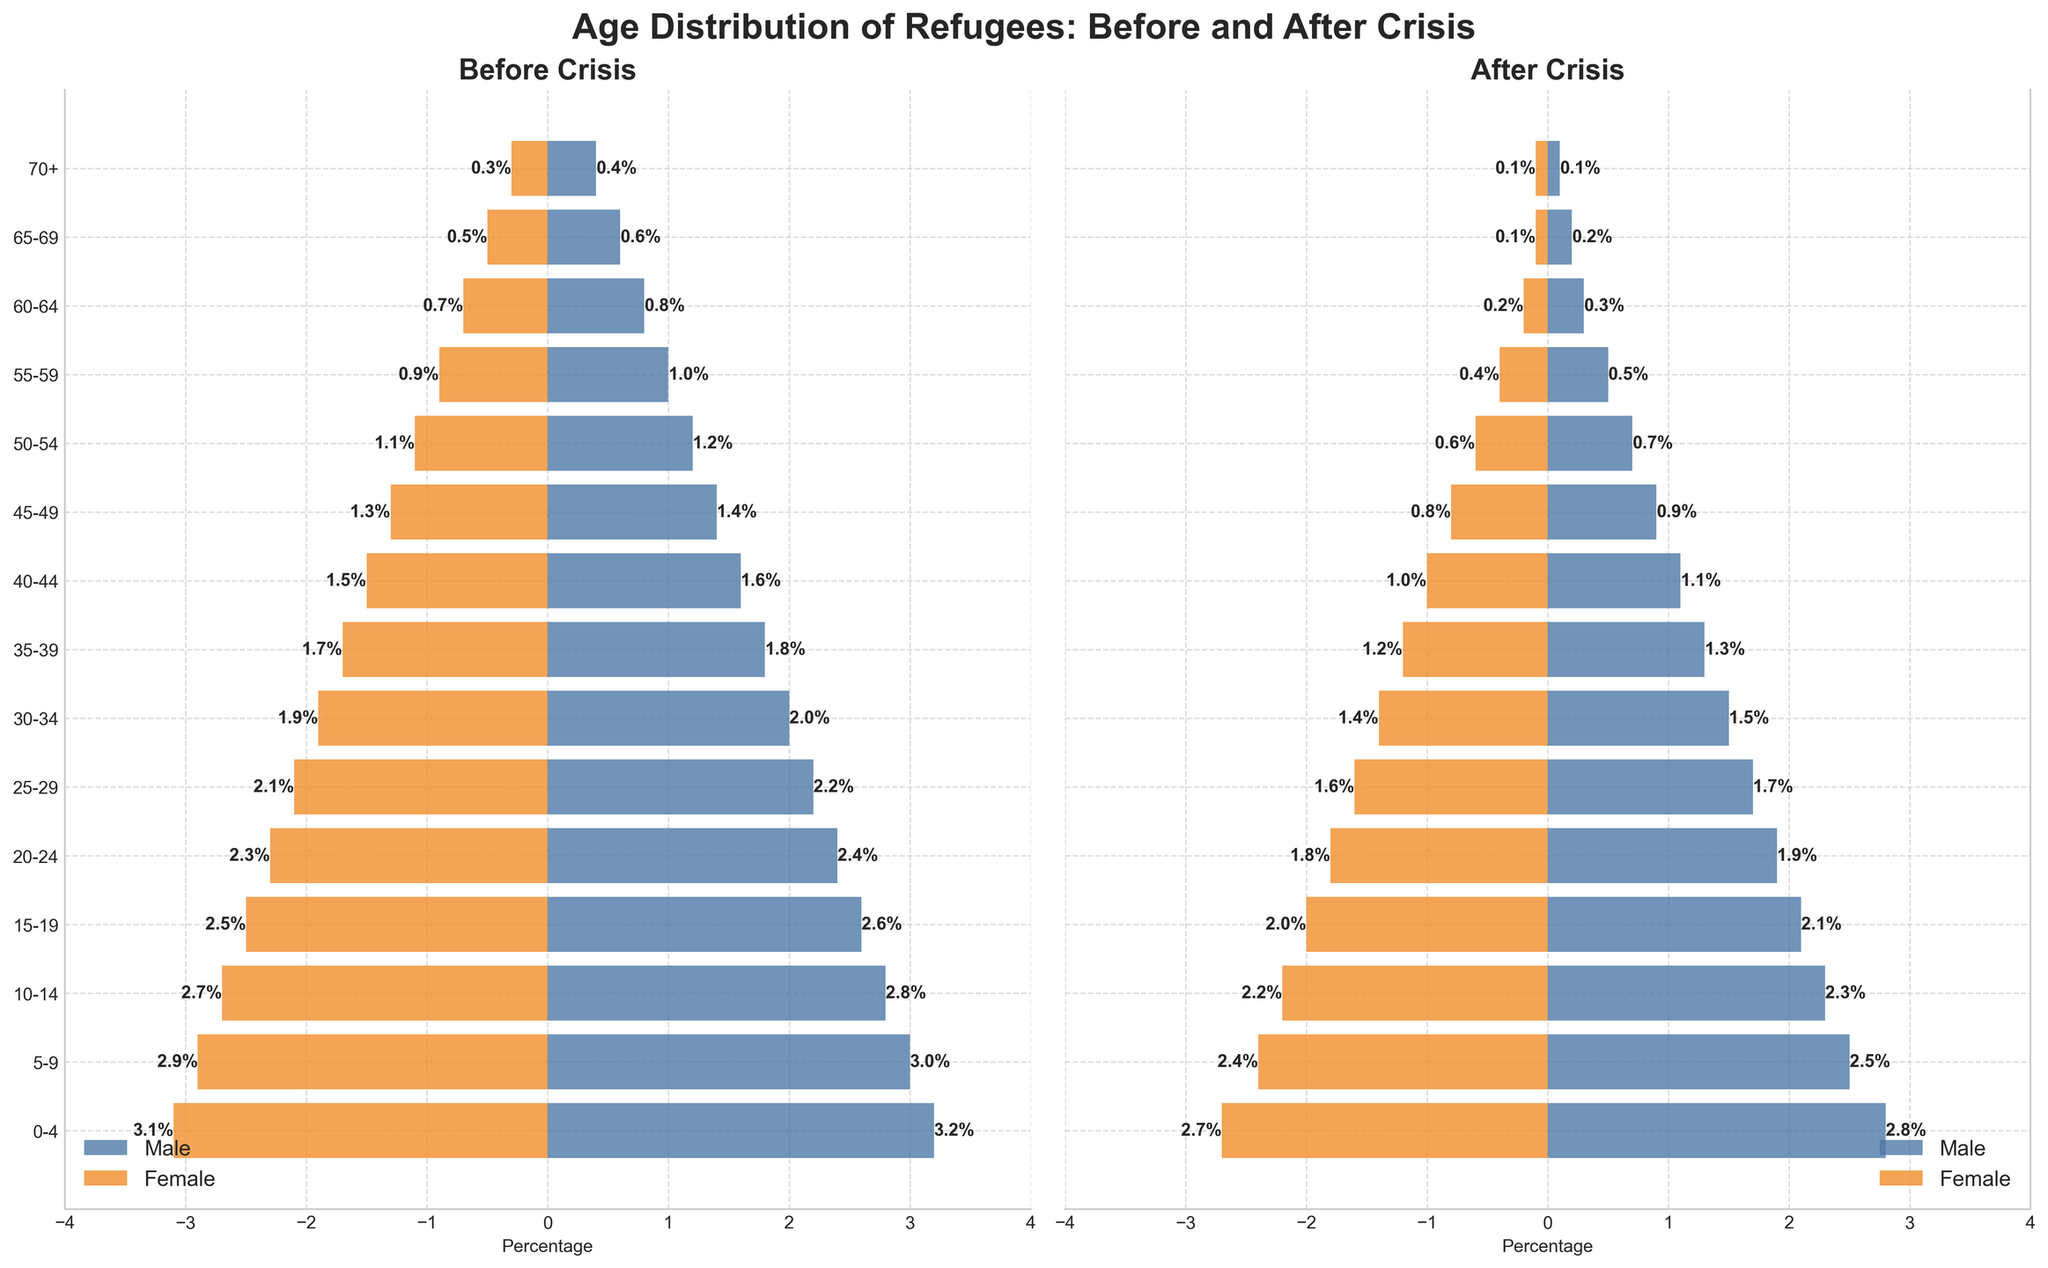What is the title of the figure? The title is displayed at the top of the figure. By looking, we can see it reads "Age Distribution of Refugees: Before and After Crisis".
Answer: Age Distribution of Refugees: Before and After Crisis What are the colors used to represent males and females in the figure? The color for males is blue and the color for females is orange, as indicated by the two distinct bars in each subplot.
Answer: Blue for males, Orange for females How many age groups are represented in the figure? Each age group is listed on the y-axis. Counting them gives us a total number.
Answer: 15 In the 'After Crisis' subplot, what percentage of refugees are males in the 30-34 age group? To find this, look at the corresponding horizontal bar for the 30-34 age group in the 'After Crisis' subplot and read the value.
Answer: 1.5% What's the difference in the percentage of males in the 50-54 age group, before and after the crisis? To solve this, subtract the 'After Crisis' value from the 'Before Crisis' value for males in the 50-54 age group. Specifically, 1.2% - 0.7% = 0.5%.
Answer: 0.5% Which age group saw the greatest decrease in the percentage of female refugees from before to after the crisis? Compare the percentage decrease for each age group by calculating the differences and identifying the largest one. The difference for the 65-69 age group is the largest, 0.5% - 0.1% = 0.4%.
Answer: 65-69 What's the total percentage of female refugees in the 10-19 age groups before the crisis? Add the percentages for females in the 10-14 and 15-19 age groups. So, 2.7% + 2.5% = 5.2%.
Answer: 5.2% Which gender saw a larger reduction in the percentage of refugees in the 0-4 age group after the crisis? Calculate the differences for both genders in the 0-4 age group, compare which one is bigger. Males decreased by 0.4% (3.2% - 2.8%) and females decreased by 0.4% (3.1% - 2.7%). They are equal.
Answer: Neither, both saw a reduction of 0.4% For the 40-44 age group after the crisis, is the percentage of male refugees higher or lower than the percentage of female refugees in the same age group? Compare the values in the respective age group for males and females in the 'After Crisis' subplot. Males have 1.1% and females have 1.0%.
Answer: Higher What is the range of percentages for the male refugees before the crisis across all age groups? Find the maximum and minimum values for the male percentages before the crisis. The highest is 3.2% and the lowest is 0.4%, so the range is 3.2% - 0.4% = 2.8%.
Answer: 2.8% 